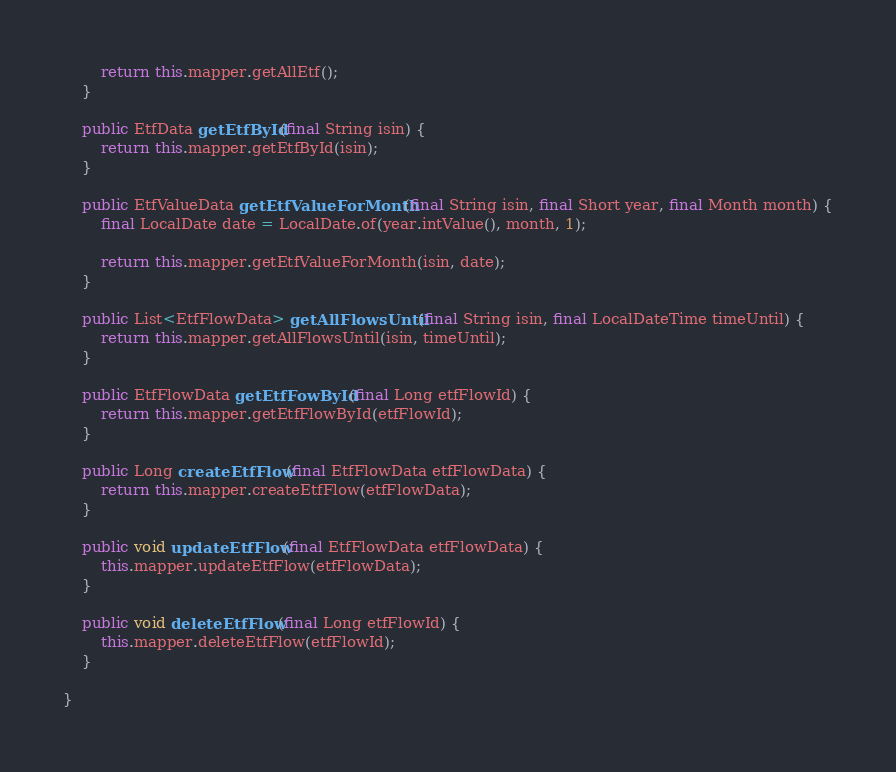Convert code to text. <code><loc_0><loc_0><loc_500><loc_500><_Java_>		return this.mapper.getAllEtf();
	}

	public EtfData getEtfById(final String isin) {
		return this.mapper.getEtfById(isin);
	}

	public EtfValueData getEtfValueForMonth(final String isin, final Short year, final Month month) {
		final LocalDate date = LocalDate.of(year.intValue(), month, 1);

		return this.mapper.getEtfValueForMonth(isin, date);
	}

	public List<EtfFlowData> getAllFlowsUntil(final String isin, final LocalDateTime timeUntil) {
		return this.mapper.getAllFlowsUntil(isin, timeUntil);
	}

	public EtfFlowData getEtfFowById(final Long etfFlowId) {
		return this.mapper.getEtfFlowById(etfFlowId);
	}

	public Long createEtfFlow(final EtfFlowData etfFlowData) {
		return this.mapper.createEtfFlow(etfFlowData);
	}

	public void updateEtfFlow(final EtfFlowData etfFlowData) {
		this.mapper.updateEtfFlow(etfFlowData);
	}

	public void deleteEtfFlow(final Long etfFlowId) {
		this.mapper.deleteEtfFlow(etfFlowId);
	}

}
</code> 